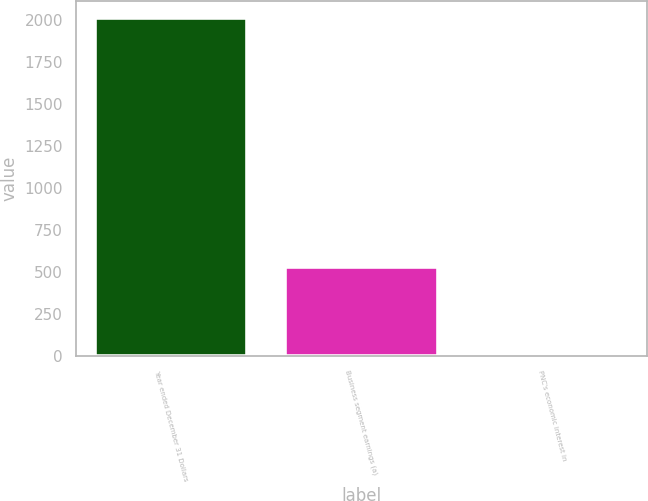Convert chart. <chart><loc_0><loc_0><loc_500><loc_500><bar_chart><fcel>Year ended December 31 Dollars<fcel>Business segment earnings (a)<fcel>PNC's economic interest in<nl><fcel>2014<fcel>530<fcel>22<nl></chart> 